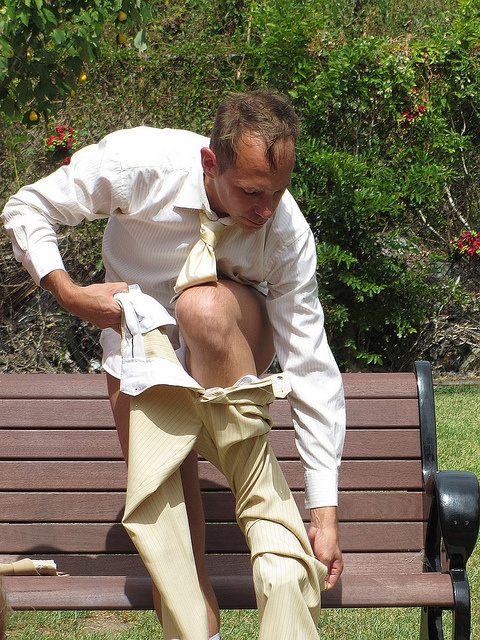Describe the objects in this image and their specific colors. I can see people in darkgreen, white, gray, darkgray, and maroon tones, bench in darkgreen, gray, black, and darkgray tones, and tie in darkgreen, ivory, tan, beige, and gray tones in this image. 